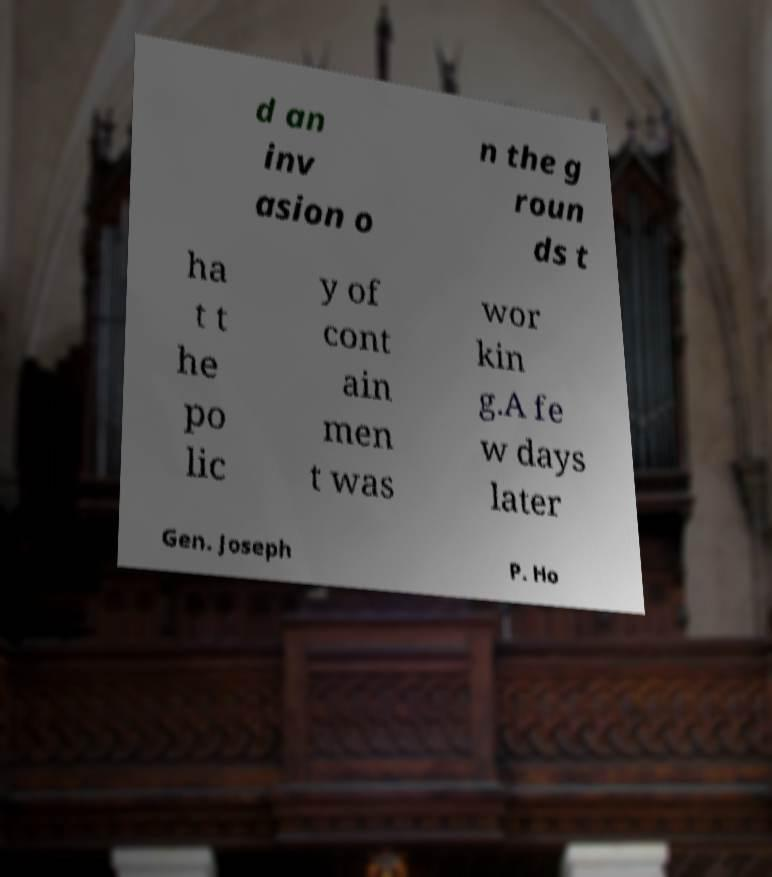Please read and relay the text visible in this image. What does it say? d an inv asion o n the g roun ds t ha t t he po lic y of cont ain men t was wor kin g.A fe w days later Gen. Joseph P. Ho 